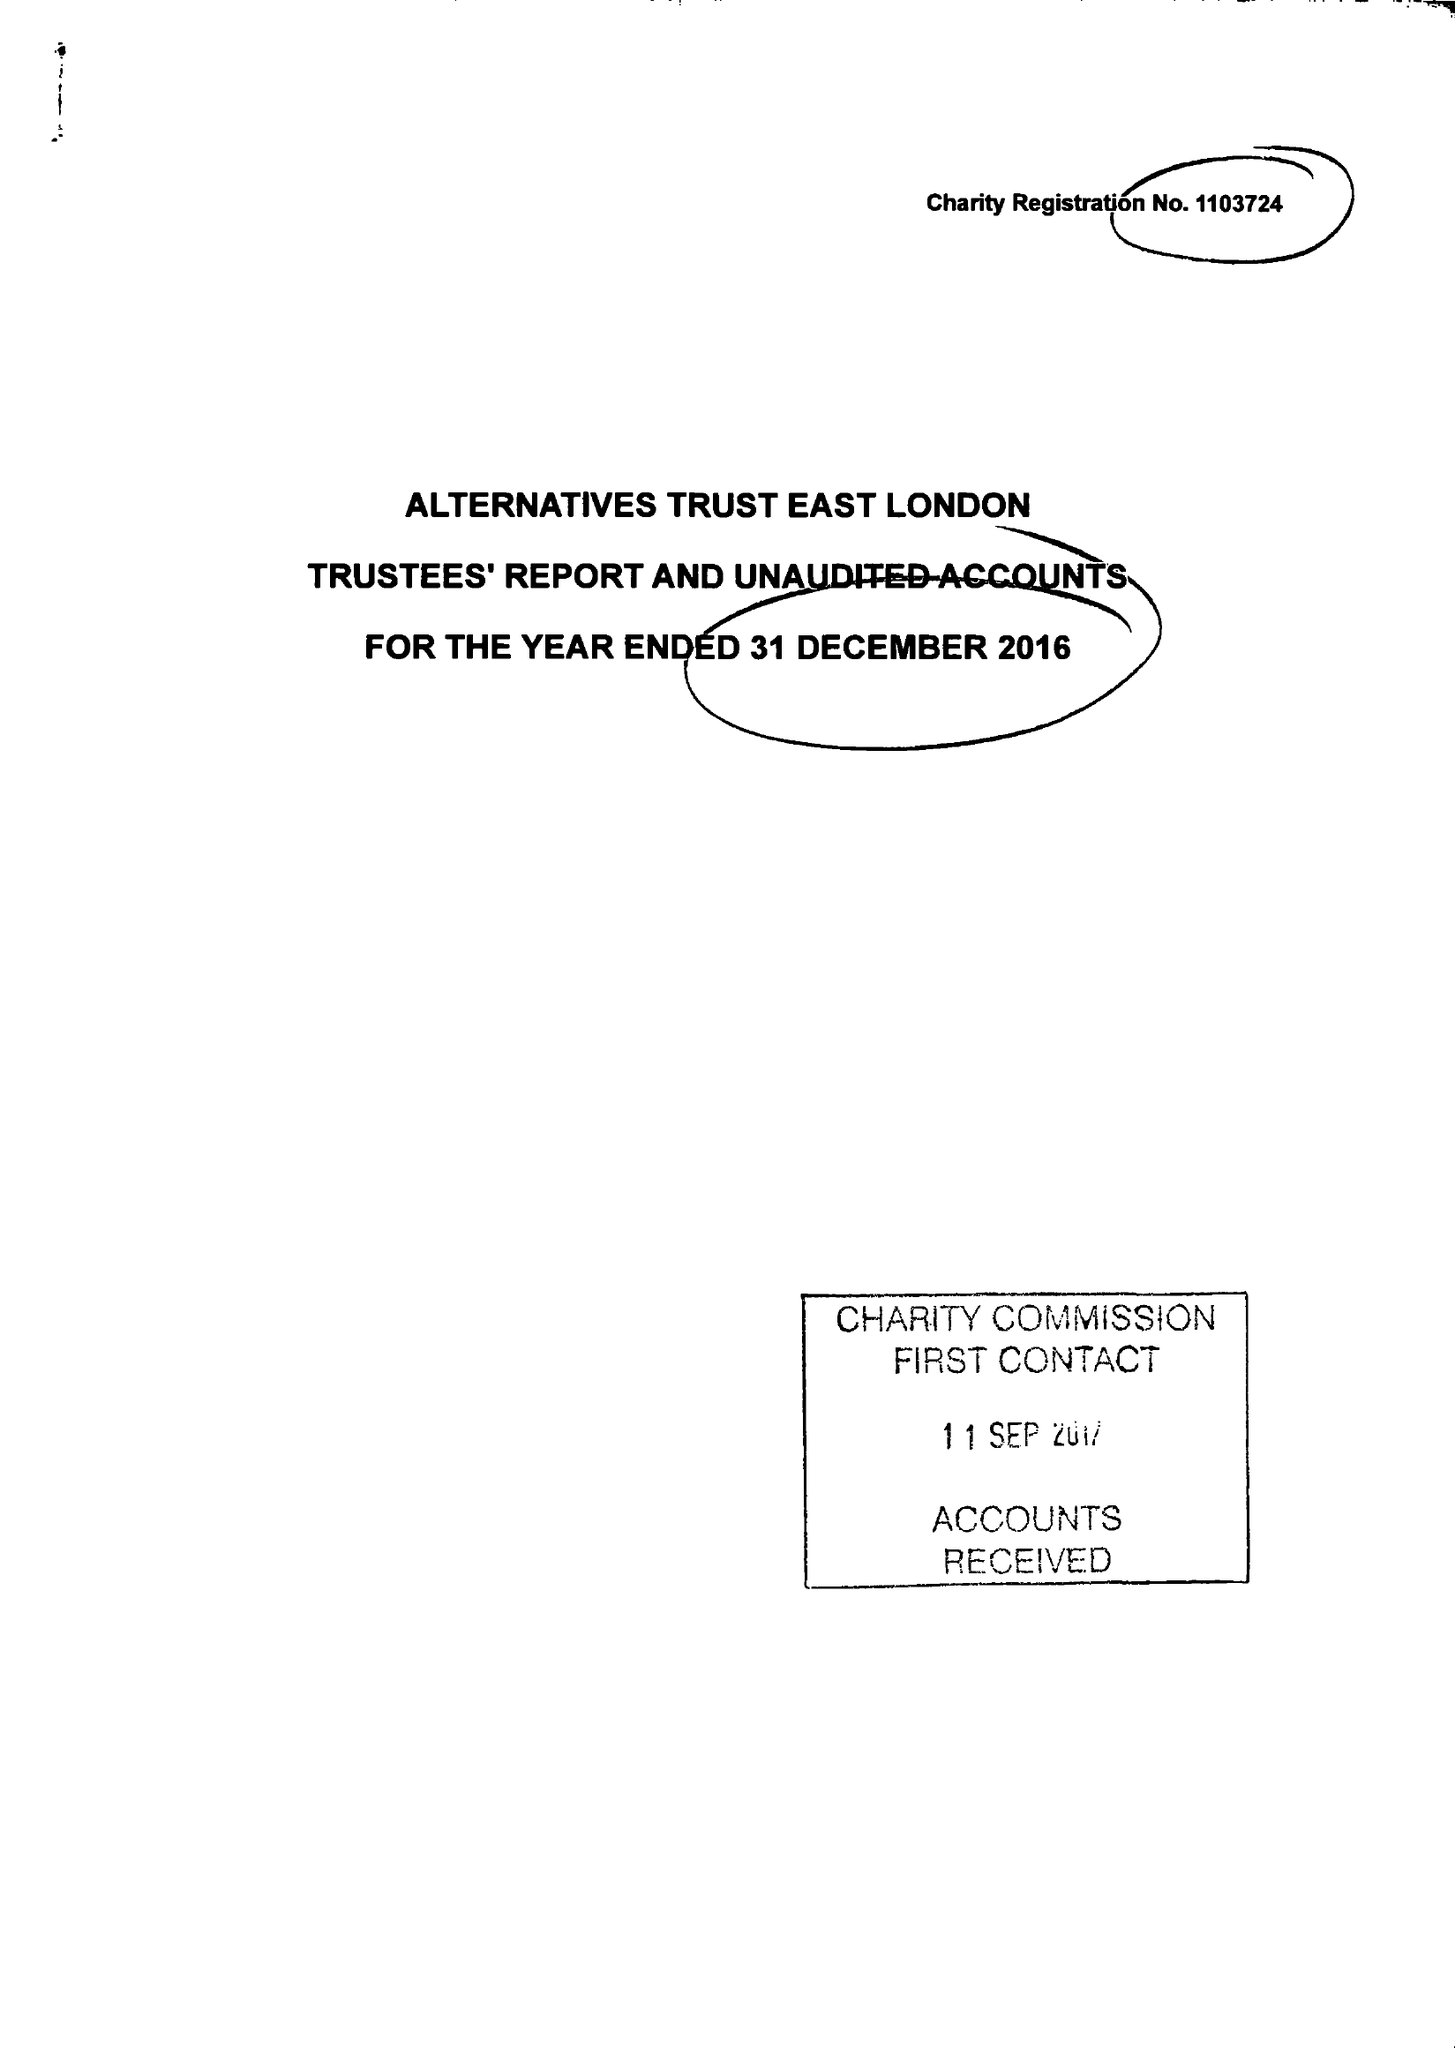What is the value for the address__post_town?
Answer the question using a single word or phrase. LONDON 